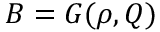Convert formula to latex. <formula><loc_0><loc_0><loc_500><loc_500>B = G ( \rho , Q )</formula> 